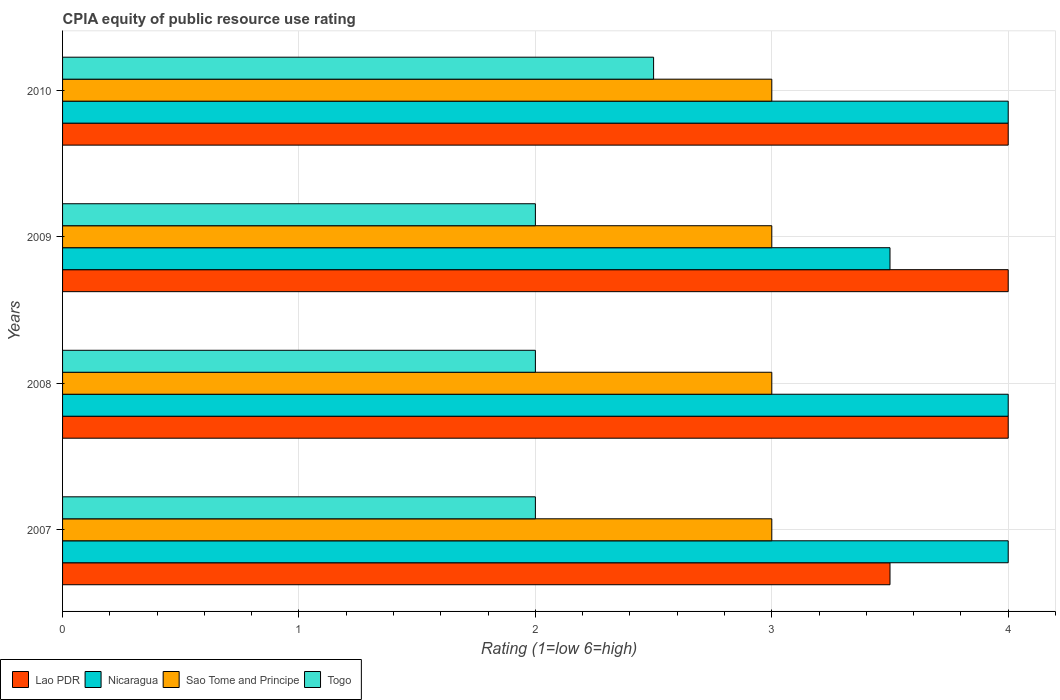Are the number of bars on each tick of the Y-axis equal?
Make the answer very short. Yes. What is the CPIA rating in Togo in 2009?
Provide a succinct answer. 2. What is the total CPIA rating in Sao Tome and Principe in the graph?
Keep it short and to the point. 12. What is the difference between the CPIA rating in Lao PDR in 2007 and that in 2010?
Provide a succinct answer. -0.5. What is the difference between the CPIA rating in Lao PDR in 2010 and the CPIA rating in Nicaragua in 2007?
Your answer should be compact. 0. What is the average CPIA rating in Nicaragua per year?
Offer a very short reply. 3.88. What is the ratio of the CPIA rating in Togo in 2007 to that in 2009?
Provide a succinct answer. 1. Is the difference between the CPIA rating in Sao Tome and Principe in 2008 and 2009 greater than the difference between the CPIA rating in Nicaragua in 2008 and 2009?
Provide a short and direct response. No. What is the difference between the highest and the second highest CPIA rating in Nicaragua?
Offer a very short reply. 0. Is the sum of the CPIA rating in Lao PDR in 2007 and 2010 greater than the maximum CPIA rating in Sao Tome and Principe across all years?
Make the answer very short. Yes. What does the 3rd bar from the top in 2010 represents?
Your response must be concise. Nicaragua. What does the 3rd bar from the bottom in 2008 represents?
Offer a very short reply. Sao Tome and Principe. Is it the case that in every year, the sum of the CPIA rating in Nicaragua and CPIA rating in Togo is greater than the CPIA rating in Lao PDR?
Your answer should be compact. Yes. Are the values on the major ticks of X-axis written in scientific E-notation?
Your answer should be compact. No. Does the graph contain grids?
Offer a very short reply. Yes. Where does the legend appear in the graph?
Provide a short and direct response. Bottom left. How many legend labels are there?
Make the answer very short. 4. What is the title of the graph?
Make the answer very short. CPIA equity of public resource use rating. Does "East Asia (all income levels)" appear as one of the legend labels in the graph?
Provide a succinct answer. No. What is the label or title of the X-axis?
Provide a short and direct response. Rating (1=low 6=high). What is the Rating (1=low 6=high) of Sao Tome and Principe in 2007?
Provide a succinct answer. 3. What is the Rating (1=low 6=high) in Nicaragua in 2008?
Your answer should be compact. 4. What is the Rating (1=low 6=high) in Sao Tome and Principe in 2008?
Your response must be concise. 3. What is the Rating (1=low 6=high) of Togo in 2008?
Make the answer very short. 2. What is the Rating (1=low 6=high) of Sao Tome and Principe in 2009?
Provide a succinct answer. 3. What is the Rating (1=low 6=high) in Togo in 2009?
Give a very brief answer. 2. What is the Rating (1=low 6=high) of Lao PDR in 2010?
Your answer should be very brief. 4. What is the Rating (1=low 6=high) of Togo in 2010?
Your response must be concise. 2.5. Across all years, what is the maximum Rating (1=low 6=high) in Lao PDR?
Ensure brevity in your answer.  4. Across all years, what is the maximum Rating (1=low 6=high) in Nicaragua?
Provide a short and direct response. 4. Across all years, what is the maximum Rating (1=low 6=high) of Sao Tome and Principe?
Offer a terse response. 3. Across all years, what is the minimum Rating (1=low 6=high) in Nicaragua?
Offer a terse response. 3.5. What is the total Rating (1=low 6=high) of Lao PDR in the graph?
Provide a short and direct response. 15.5. What is the difference between the Rating (1=low 6=high) in Nicaragua in 2007 and that in 2008?
Offer a terse response. 0. What is the difference between the Rating (1=low 6=high) in Sao Tome and Principe in 2007 and that in 2008?
Ensure brevity in your answer.  0. What is the difference between the Rating (1=low 6=high) of Lao PDR in 2007 and that in 2009?
Ensure brevity in your answer.  -0.5. What is the difference between the Rating (1=low 6=high) of Nicaragua in 2007 and that in 2010?
Provide a short and direct response. 0. What is the difference between the Rating (1=low 6=high) of Togo in 2007 and that in 2010?
Ensure brevity in your answer.  -0.5. What is the difference between the Rating (1=low 6=high) of Lao PDR in 2008 and that in 2009?
Your response must be concise. 0. What is the difference between the Rating (1=low 6=high) in Sao Tome and Principe in 2008 and that in 2009?
Keep it short and to the point. 0. What is the difference between the Rating (1=low 6=high) of Lao PDR in 2008 and that in 2010?
Offer a very short reply. 0. What is the difference between the Rating (1=low 6=high) in Nicaragua in 2008 and that in 2010?
Make the answer very short. 0. What is the difference between the Rating (1=low 6=high) in Lao PDR in 2009 and that in 2010?
Make the answer very short. 0. What is the difference between the Rating (1=low 6=high) of Nicaragua in 2009 and that in 2010?
Offer a terse response. -0.5. What is the difference between the Rating (1=low 6=high) of Togo in 2009 and that in 2010?
Your answer should be compact. -0.5. What is the difference between the Rating (1=low 6=high) of Lao PDR in 2007 and the Rating (1=low 6=high) of Nicaragua in 2008?
Provide a succinct answer. -0.5. What is the difference between the Rating (1=low 6=high) of Nicaragua in 2007 and the Rating (1=low 6=high) of Sao Tome and Principe in 2008?
Offer a very short reply. 1. What is the difference between the Rating (1=low 6=high) of Lao PDR in 2007 and the Rating (1=low 6=high) of Togo in 2009?
Offer a very short reply. 1.5. What is the difference between the Rating (1=low 6=high) in Nicaragua in 2007 and the Rating (1=low 6=high) in Togo in 2009?
Give a very brief answer. 2. What is the difference between the Rating (1=low 6=high) of Lao PDR in 2007 and the Rating (1=low 6=high) of Nicaragua in 2010?
Your answer should be compact. -0.5. What is the difference between the Rating (1=low 6=high) of Lao PDR in 2007 and the Rating (1=low 6=high) of Sao Tome and Principe in 2010?
Make the answer very short. 0.5. What is the difference between the Rating (1=low 6=high) in Lao PDR in 2007 and the Rating (1=low 6=high) in Togo in 2010?
Your response must be concise. 1. What is the difference between the Rating (1=low 6=high) in Nicaragua in 2007 and the Rating (1=low 6=high) in Sao Tome and Principe in 2010?
Provide a short and direct response. 1. What is the difference between the Rating (1=low 6=high) in Nicaragua in 2007 and the Rating (1=low 6=high) in Togo in 2010?
Give a very brief answer. 1.5. What is the difference between the Rating (1=low 6=high) of Lao PDR in 2008 and the Rating (1=low 6=high) of Sao Tome and Principe in 2009?
Your answer should be very brief. 1. What is the difference between the Rating (1=low 6=high) of Nicaragua in 2008 and the Rating (1=low 6=high) of Sao Tome and Principe in 2009?
Your answer should be very brief. 1. What is the difference between the Rating (1=low 6=high) of Nicaragua in 2008 and the Rating (1=low 6=high) of Togo in 2009?
Ensure brevity in your answer.  2. What is the difference between the Rating (1=low 6=high) of Sao Tome and Principe in 2008 and the Rating (1=low 6=high) of Togo in 2009?
Offer a very short reply. 1. What is the difference between the Rating (1=low 6=high) in Lao PDR in 2008 and the Rating (1=low 6=high) in Togo in 2010?
Ensure brevity in your answer.  1.5. What is the difference between the Rating (1=low 6=high) of Nicaragua in 2008 and the Rating (1=low 6=high) of Sao Tome and Principe in 2010?
Ensure brevity in your answer.  1. What is the difference between the Rating (1=low 6=high) of Lao PDR in 2009 and the Rating (1=low 6=high) of Nicaragua in 2010?
Give a very brief answer. 0. What is the difference between the Rating (1=low 6=high) of Lao PDR in 2009 and the Rating (1=low 6=high) of Sao Tome and Principe in 2010?
Keep it short and to the point. 1. What is the difference between the Rating (1=low 6=high) in Nicaragua in 2009 and the Rating (1=low 6=high) in Sao Tome and Principe in 2010?
Give a very brief answer. 0.5. What is the difference between the Rating (1=low 6=high) in Nicaragua in 2009 and the Rating (1=low 6=high) in Togo in 2010?
Provide a succinct answer. 1. What is the difference between the Rating (1=low 6=high) in Sao Tome and Principe in 2009 and the Rating (1=low 6=high) in Togo in 2010?
Provide a succinct answer. 0.5. What is the average Rating (1=low 6=high) in Lao PDR per year?
Provide a short and direct response. 3.88. What is the average Rating (1=low 6=high) in Nicaragua per year?
Offer a terse response. 3.88. What is the average Rating (1=low 6=high) of Sao Tome and Principe per year?
Your response must be concise. 3. What is the average Rating (1=low 6=high) in Togo per year?
Make the answer very short. 2.12. In the year 2007, what is the difference between the Rating (1=low 6=high) of Lao PDR and Rating (1=low 6=high) of Sao Tome and Principe?
Provide a short and direct response. 0.5. In the year 2007, what is the difference between the Rating (1=low 6=high) of Sao Tome and Principe and Rating (1=low 6=high) of Togo?
Keep it short and to the point. 1. In the year 2008, what is the difference between the Rating (1=low 6=high) in Lao PDR and Rating (1=low 6=high) in Nicaragua?
Offer a terse response. 0. In the year 2008, what is the difference between the Rating (1=low 6=high) of Lao PDR and Rating (1=low 6=high) of Sao Tome and Principe?
Provide a succinct answer. 1. In the year 2008, what is the difference between the Rating (1=low 6=high) of Nicaragua and Rating (1=low 6=high) of Togo?
Your answer should be very brief. 2. In the year 2009, what is the difference between the Rating (1=low 6=high) in Lao PDR and Rating (1=low 6=high) in Togo?
Ensure brevity in your answer.  2. In the year 2009, what is the difference between the Rating (1=low 6=high) of Nicaragua and Rating (1=low 6=high) of Sao Tome and Principe?
Keep it short and to the point. 0.5. In the year 2009, what is the difference between the Rating (1=low 6=high) in Nicaragua and Rating (1=low 6=high) in Togo?
Give a very brief answer. 1.5. In the year 2009, what is the difference between the Rating (1=low 6=high) of Sao Tome and Principe and Rating (1=low 6=high) of Togo?
Keep it short and to the point. 1. In the year 2010, what is the difference between the Rating (1=low 6=high) of Lao PDR and Rating (1=low 6=high) of Nicaragua?
Offer a very short reply. 0. In the year 2010, what is the difference between the Rating (1=low 6=high) in Lao PDR and Rating (1=low 6=high) in Sao Tome and Principe?
Ensure brevity in your answer.  1. In the year 2010, what is the difference between the Rating (1=low 6=high) of Lao PDR and Rating (1=low 6=high) of Togo?
Give a very brief answer. 1.5. In the year 2010, what is the difference between the Rating (1=low 6=high) in Nicaragua and Rating (1=low 6=high) in Sao Tome and Principe?
Your answer should be very brief. 1. What is the ratio of the Rating (1=low 6=high) of Lao PDR in 2007 to that in 2008?
Offer a terse response. 0.88. What is the ratio of the Rating (1=low 6=high) in Sao Tome and Principe in 2007 to that in 2008?
Offer a terse response. 1. What is the ratio of the Rating (1=low 6=high) of Lao PDR in 2007 to that in 2009?
Your answer should be very brief. 0.88. What is the ratio of the Rating (1=low 6=high) of Sao Tome and Principe in 2007 to that in 2009?
Ensure brevity in your answer.  1. What is the ratio of the Rating (1=low 6=high) in Lao PDR in 2007 to that in 2010?
Make the answer very short. 0.88. What is the ratio of the Rating (1=low 6=high) in Togo in 2007 to that in 2010?
Provide a short and direct response. 0.8. What is the ratio of the Rating (1=low 6=high) in Lao PDR in 2008 to that in 2009?
Your answer should be very brief. 1. What is the ratio of the Rating (1=low 6=high) of Nicaragua in 2008 to that in 2009?
Give a very brief answer. 1.14. What is the ratio of the Rating (1=low 6=high) of Sao Tome and Principe in 2008 to that in 2009?
Provide a short and direct response. 1. What is the ratio of the Rating (1=low 6=high) in Togo in 2008 to that in 2009?
Give a very brief answer. 1. What is the ratio of the Rating (1=low 6=high) in Sao Tome and Principe in 2009 to that in 2010?
Offer a very short reply. 1. What is the difference between the highest and the second highest Rating (1=low 6=high) of Lao PDR?
Offer a very short reply. 0. What is the difference between the highest and the second highest Rating (1=low 6=high) of Nicaragua?
Your answer should be very brief. 0. What is the difference between the highest and the second highest Rating (1=low 6=high) in Togo?
Keep it short and to the point. 0.5. What is the difference between the highest and the lowest Rating (1=low 6=high) of Nicaragua?
Give a very brief answer. 0.5. 